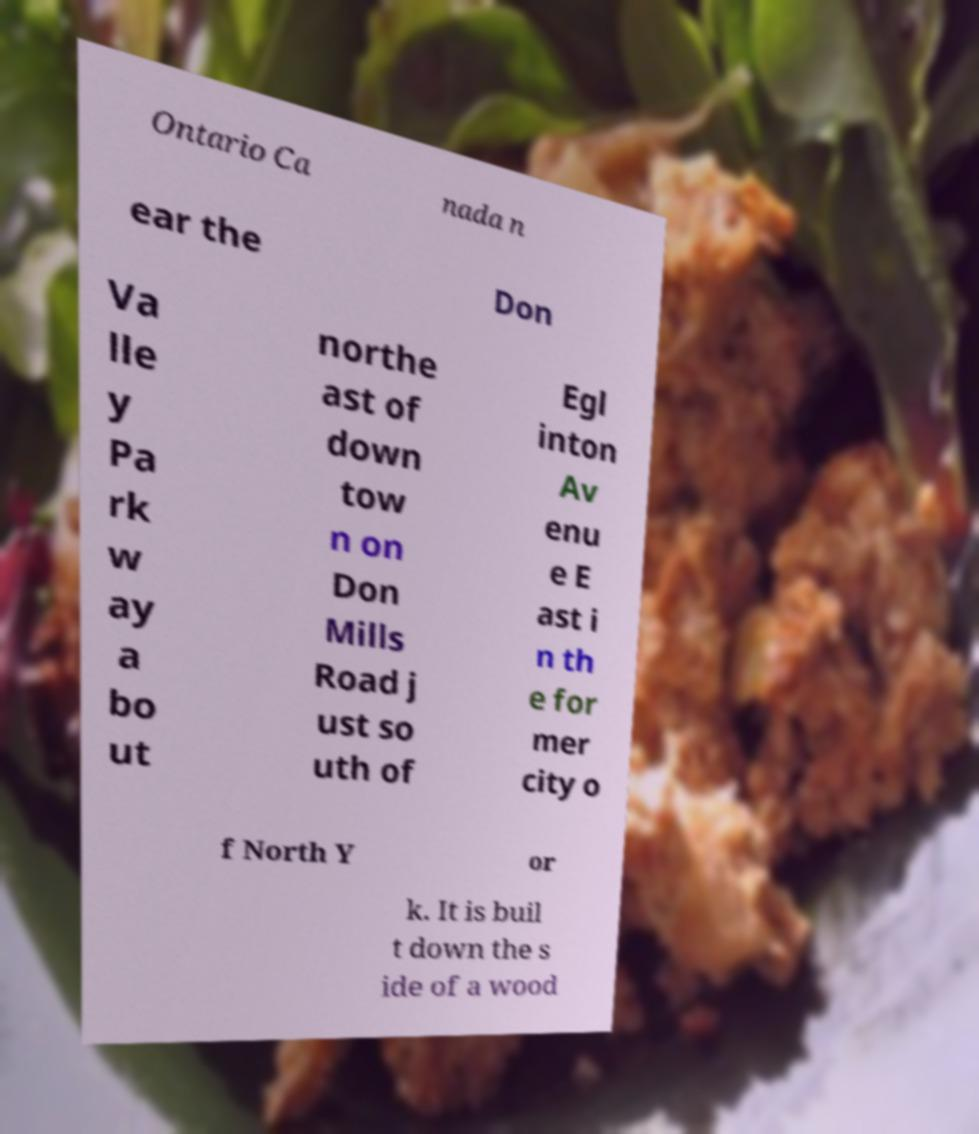Can you accurately transcribe the text from the provided image for me? Ontario Ca nada n ear the Don Va lle y Pa rk w ay a bo ut northe ast of down tow n on Don Mills Road j ust so uth of Egl inton Av enu e E ast i n th e for mer city o f North Y or k. It is buil t down the s ide of a wood 